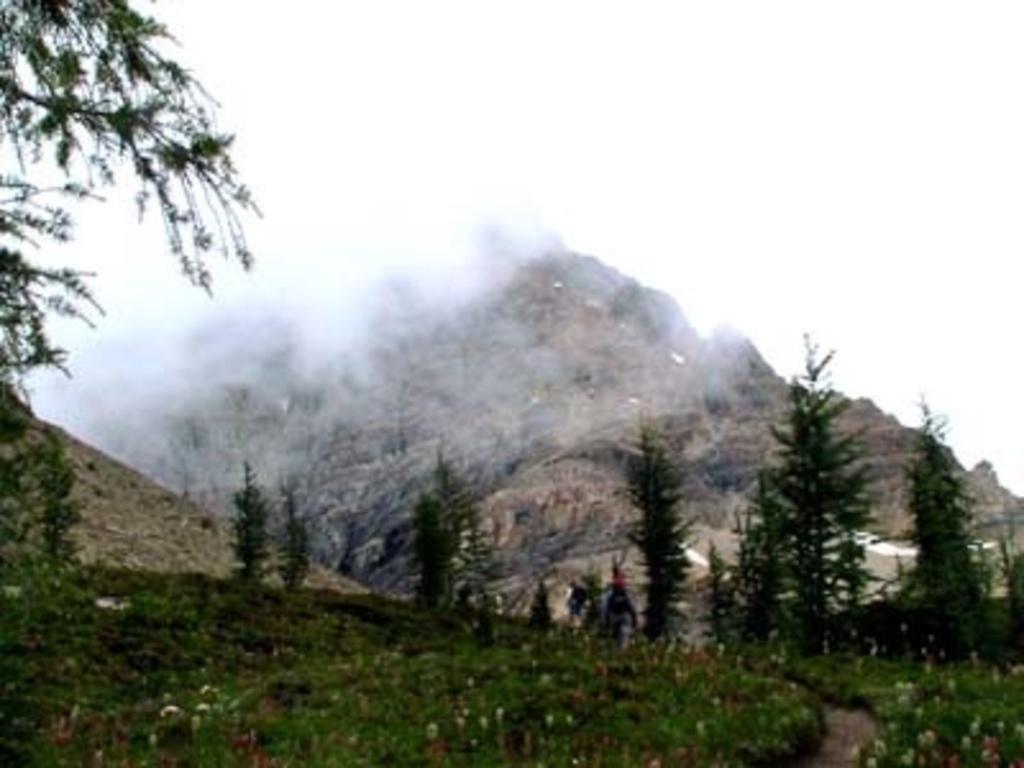Can you describe this image briefly? At the bottom of this image, there are plants and trees on the ground. In the background, there are mountains and there are clouds in the sky. 